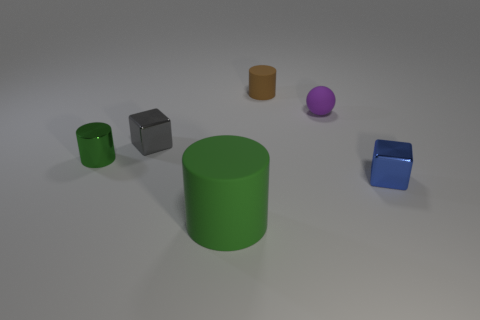Add 1 big cyan cylinders. How many objects exist? 7 Subtract all cubes. How many objects are left? 4 Add 3 big green matte objects. How many big green matte objects are left? 4 Add 1 tiny gray cubes. How many tiny gray cubes exist? 2 Subtract 0 yellow cylinders. How many objects are left? 6 Subtract all tiny balls. Subtract all small blocks. How many objects are left? 3 